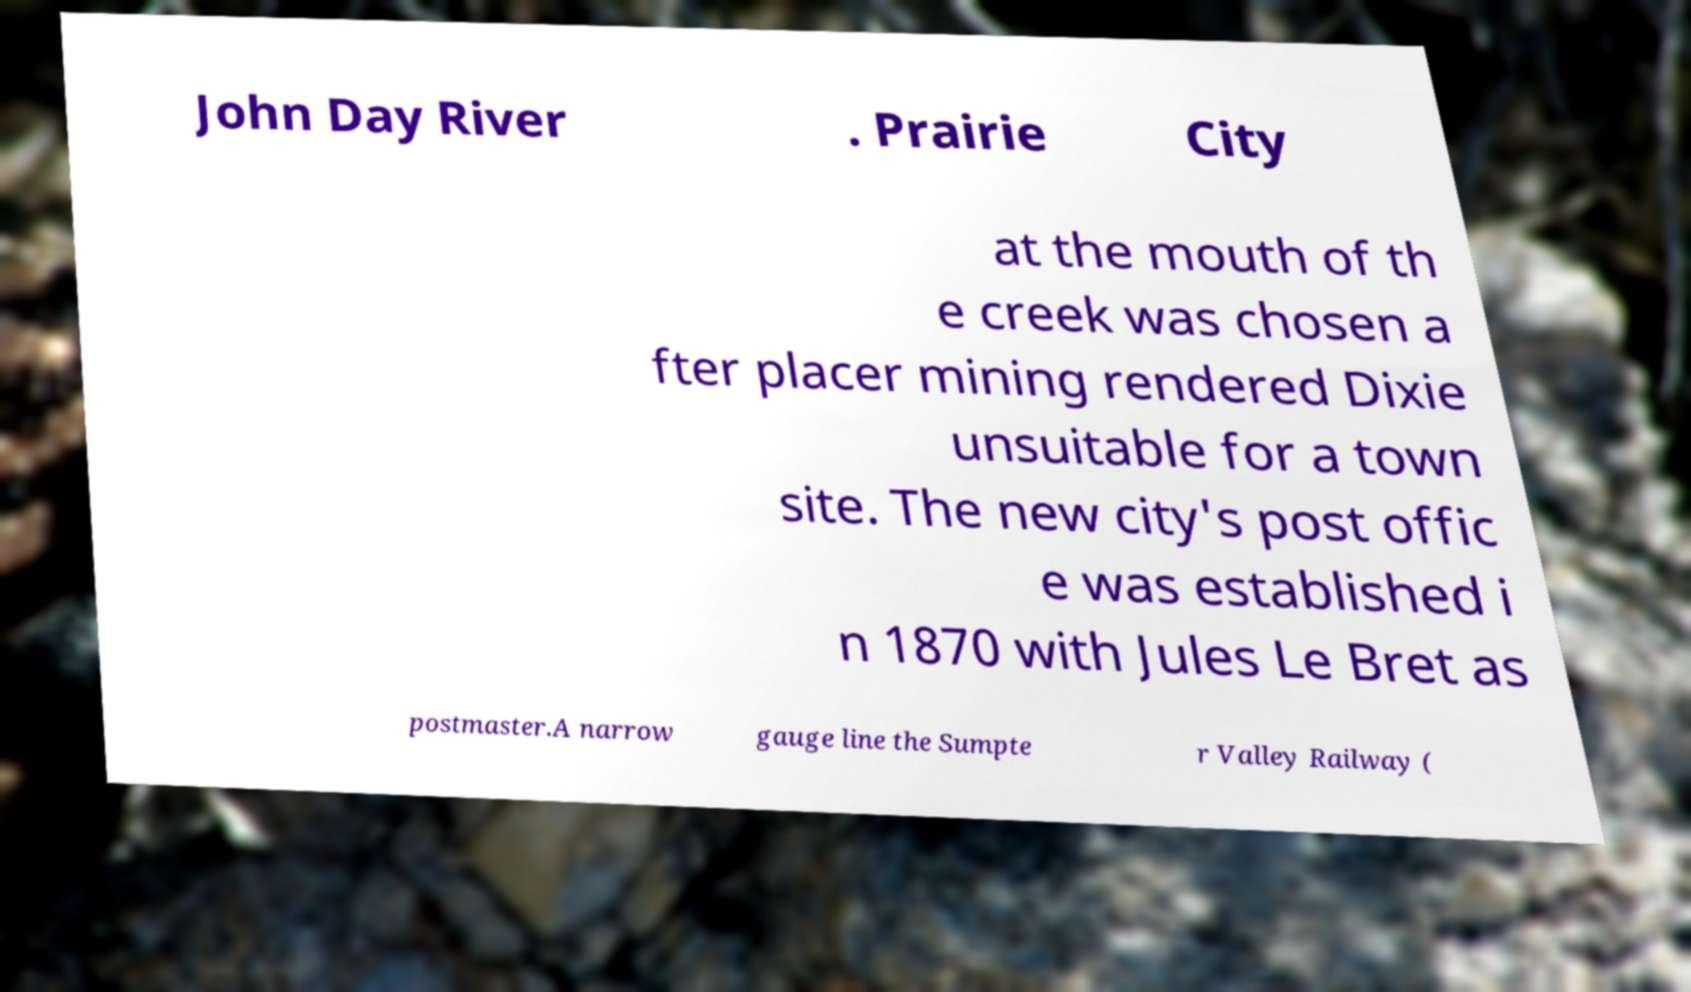I need the written content from this picture converted into text. Can you do that? John Day River . Prairie City at the mouth of th e creek was chosen a fter placer mining rendered Dixie unsuitable for a town site. The new city's post offic e was established i n 1870 with Jules Le Bret as postmaster.A narrow gauge line the Sumpte r Valley Railway ( 